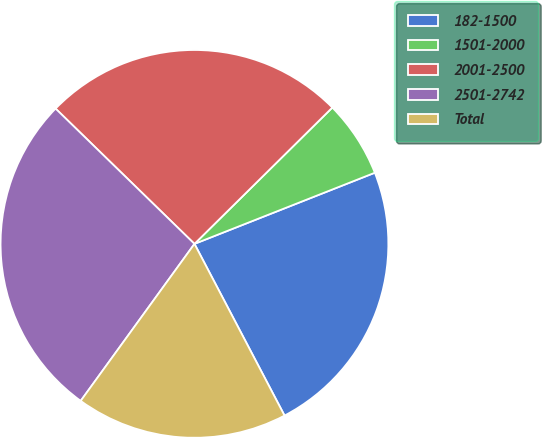Convert chart. <chart><loc_0><loc_0><loc_500><loc_500><pie_chart><fcel>182-1500<fcel>1501-2000<fcel>2001-2500<fcel>2501-2742<fcel>Total<nl><fcel>23.29%<fcel>6.43%<fcel>25.3%<fcel>27.31%<fcel>17.67%<nl></chart> 